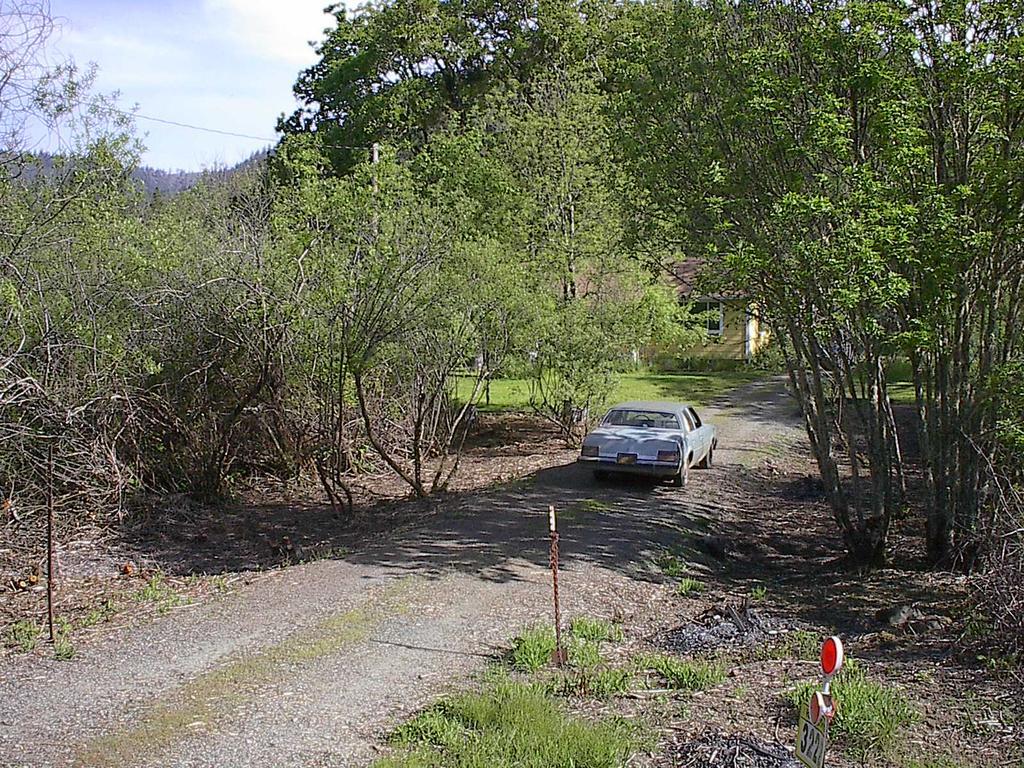In one or two sentences, can you explain what this image depicts? At the center of the image there is a moving car on the road. On the either sides of the road there are trees. In the middle of the trees there is a house. In the background there is a sky. 